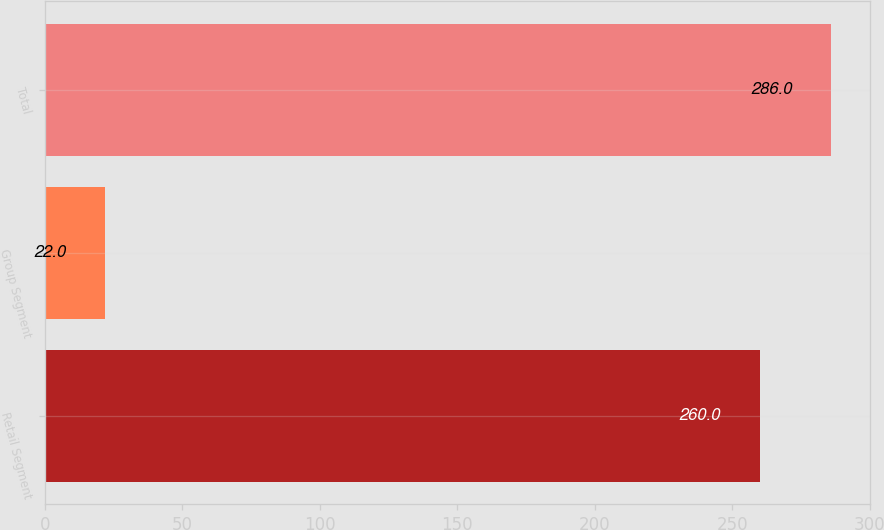Convert chart. <chart><loc_0><loc_0><loc_500><loc_500><bar_chart><fcel>Retail Segment<fcel>Group Segment<fcel>Total<nl><fcel>260<fcel>22<fcel>286<nl></chart> 